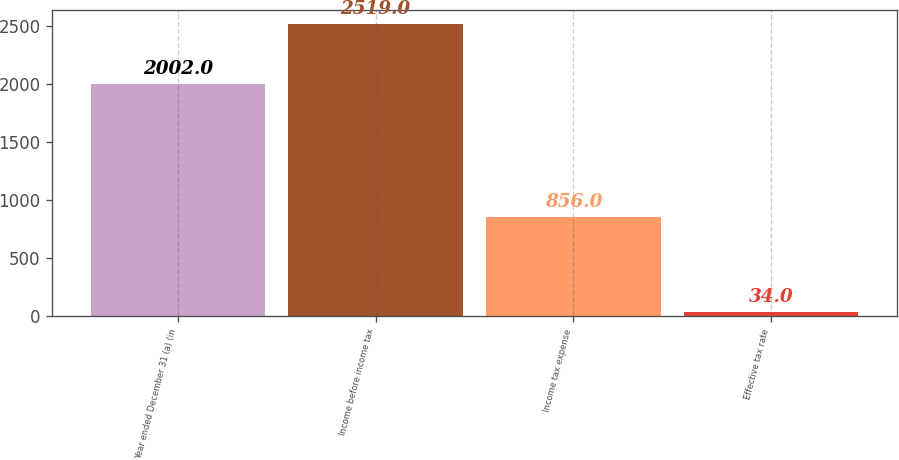<chart> <loc_0><loc_0><loc_500><loc_500><bar_chart><fcel>Year ended December 31 (a) (in<fcel>Income before income tax<fcel>Income tax expense<fcel>Effective tax rate<nl><fcel>2002<fcel>2519<fcel>856<fcel>34<nl></chart> 